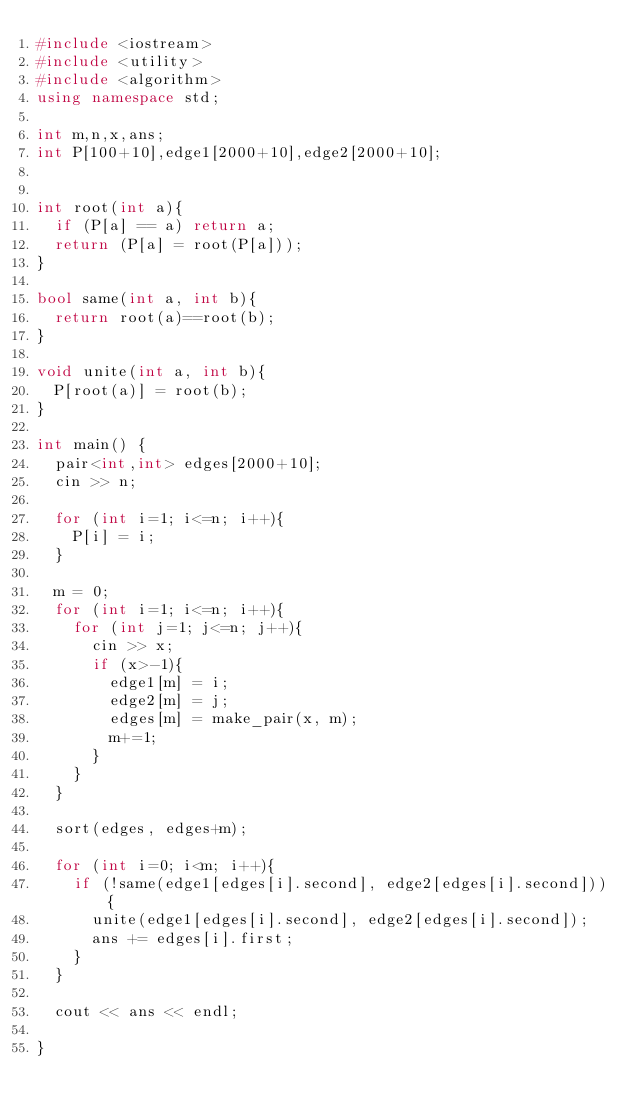Convert code to text. <code><loc_0><loc_0><loc_500><loc_500><_C++_>#include <iostream>
#include <utility>
#include <algorithm>
using namespace std;

int m,n,x,ans;
int P[100+10],edge1[2000+10],edge2[2000+10];


int root(int a){
	if (P[a] == a) return a;
	return (P[a] = root(P[a]));
}

bool same(int a, int b){
	return root(a)==root(b);
}
	
void unite(int a, int b){
	P[root(a)] = root(b);
}

int main() {
	pair<int,int> edges[2000+10];
	cin >> n;
	
	for (int i=1; i<=n; i++){
		P[i] = i;
	}
	
	m = 0;
	for (int i=1; i<=n; i++){
		for (int j=1; j<=n; j++){
			cin >> x;
			if (x>-1){
				edge1[m] = i;
				edge2[m] = j;
				edges[m] = make_pair(x, m);
				m+=1;
			}
		}
	}
	
	sort(edges, edges+m);
	
	for (int i=0; i<m; i++){
		if (!same(edge1[edges[i].second], edge2[edges[i].second])){
			unite(edge1[edges[i].second], edge2[edges[i].second]);
			ans += edges[i].first;
		}
	}
	
	cout << ans << endl;
	
}</code> 